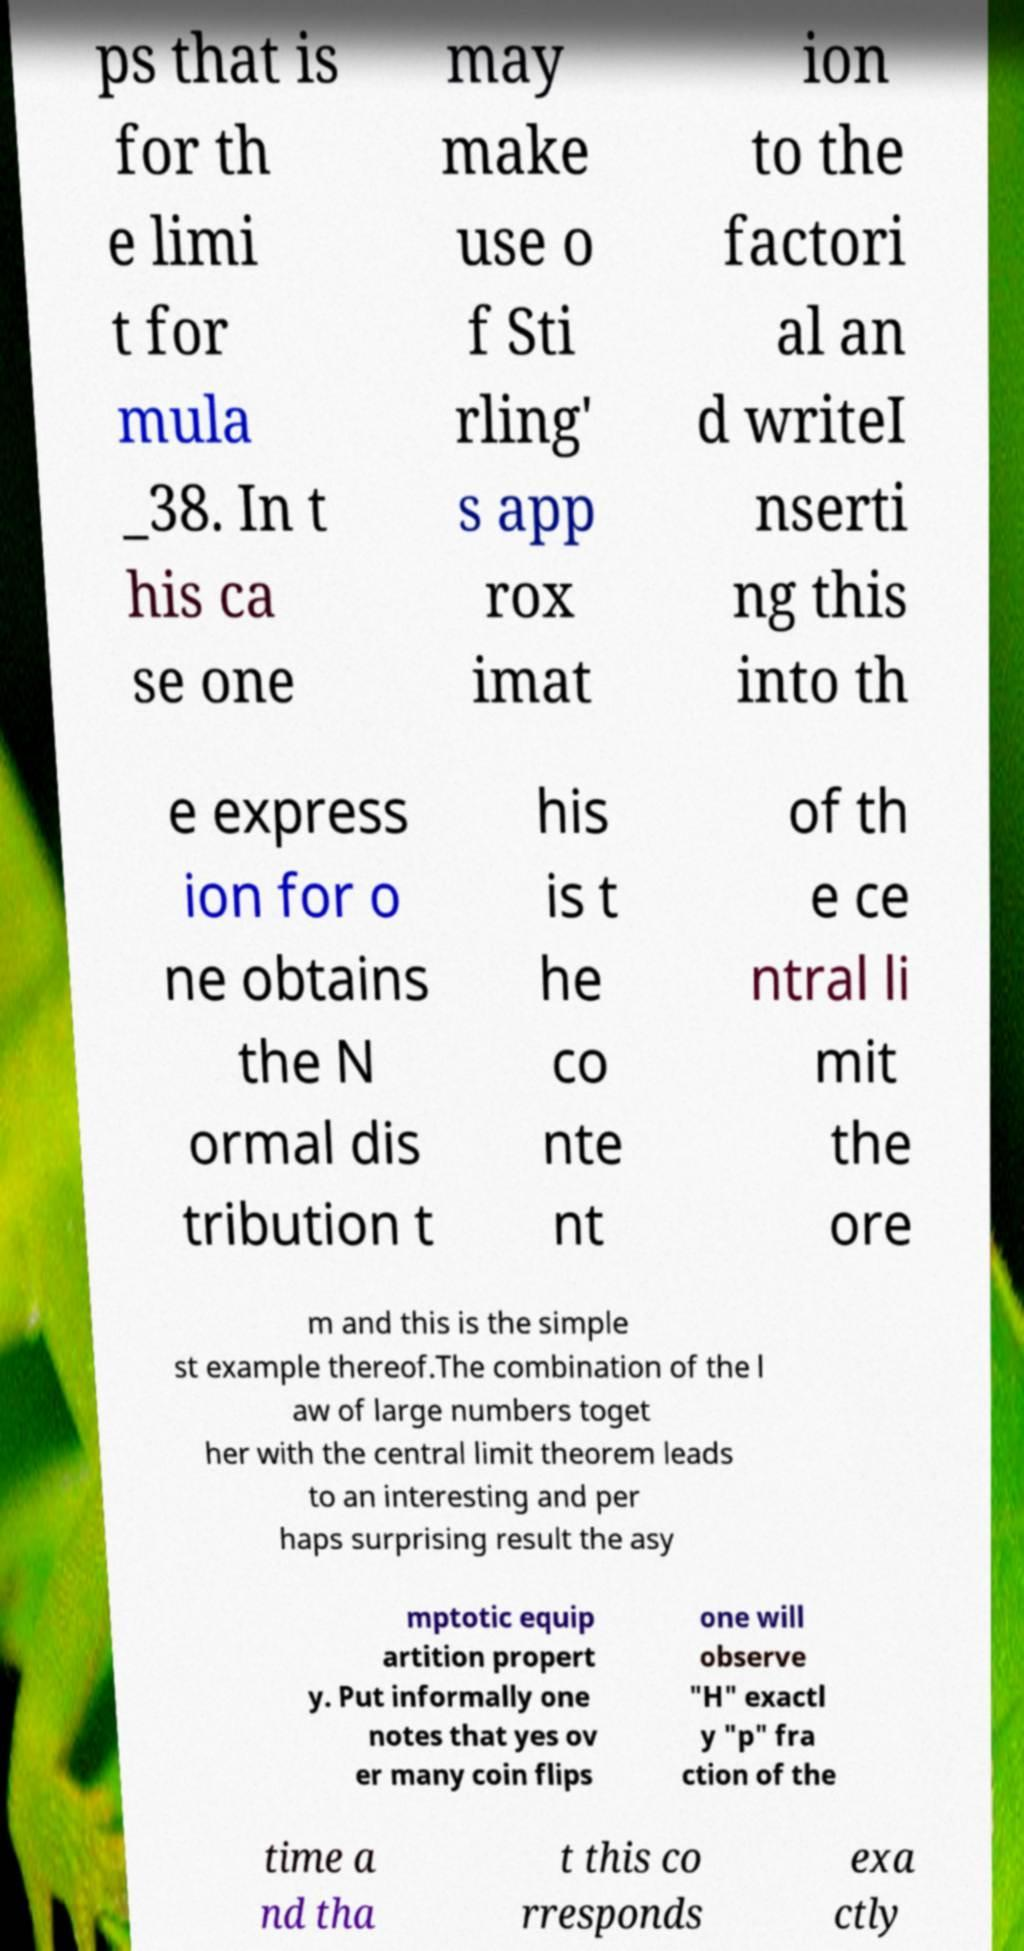Can you accurately transcribe the text from the provided image for me? ps that is for th e limi t for mula _38. In t his ca se one may make use o f Sti rling' s app rox imat ion to the factori al an d writeI nserti ng this into th e express ion for o ne obtains the N ormal dis tribution t his is t he co nte nt of th e ce ntral li mit the ore m and this is the simple st example thereof.The combination of the l aw of large numbers toget her with the central limit theorem leads to an interesting and per haps surprising result the asy mptotic equip artition propert y. Put informally one notes that yes ov er many coin flips one will observe "H" exactl y "p" fra ction of the time a nd tha t this co rresponds exa ctly 